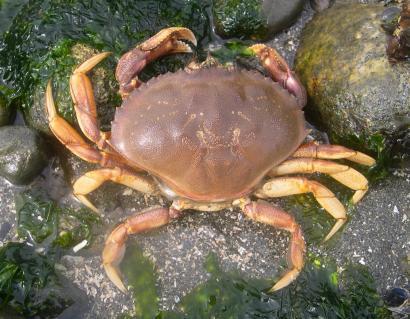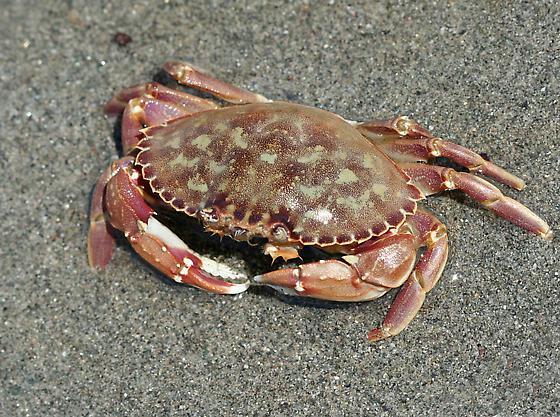The first image is the image on the left, the second image is the image on the right. For the images displayed, is the sentence "Each image is a from-the-top view of one crab, but one image shows a crab with its face and front claws on the top, and one shows them at the bottom." factually correct? Answer yes or no. Yes. The first image is the image on the left, the second image is the image on the right. For the images displayed, is the sentence "Crabs are facing in opposite directions." factually correct? Answer yes or no. Yes. 